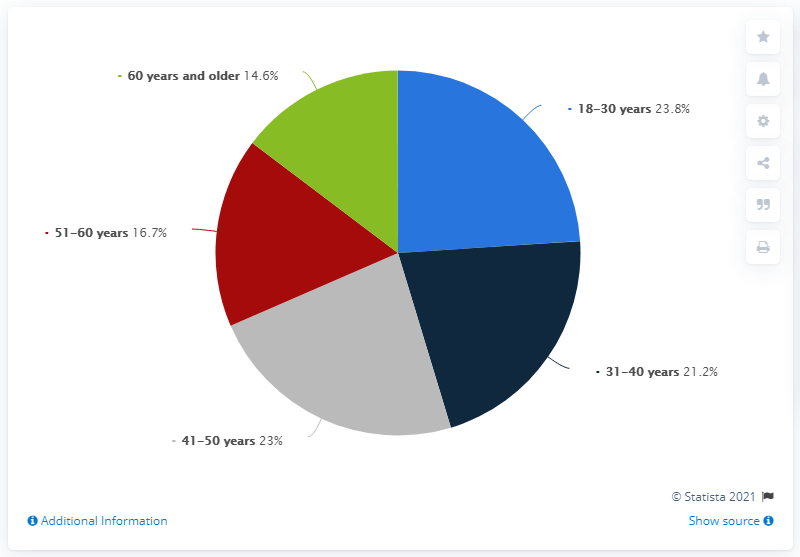Outline some significant characteristics in this image. In 2019, approximately 23% of scam victims in Italy were between the ages of 41 and 50. Young adults in Italy were scammed at a higher rate than middle-aged individuals, with a difference of 2.6%. In 2019, approximately 23.8% of Italians fell victim to scams. 